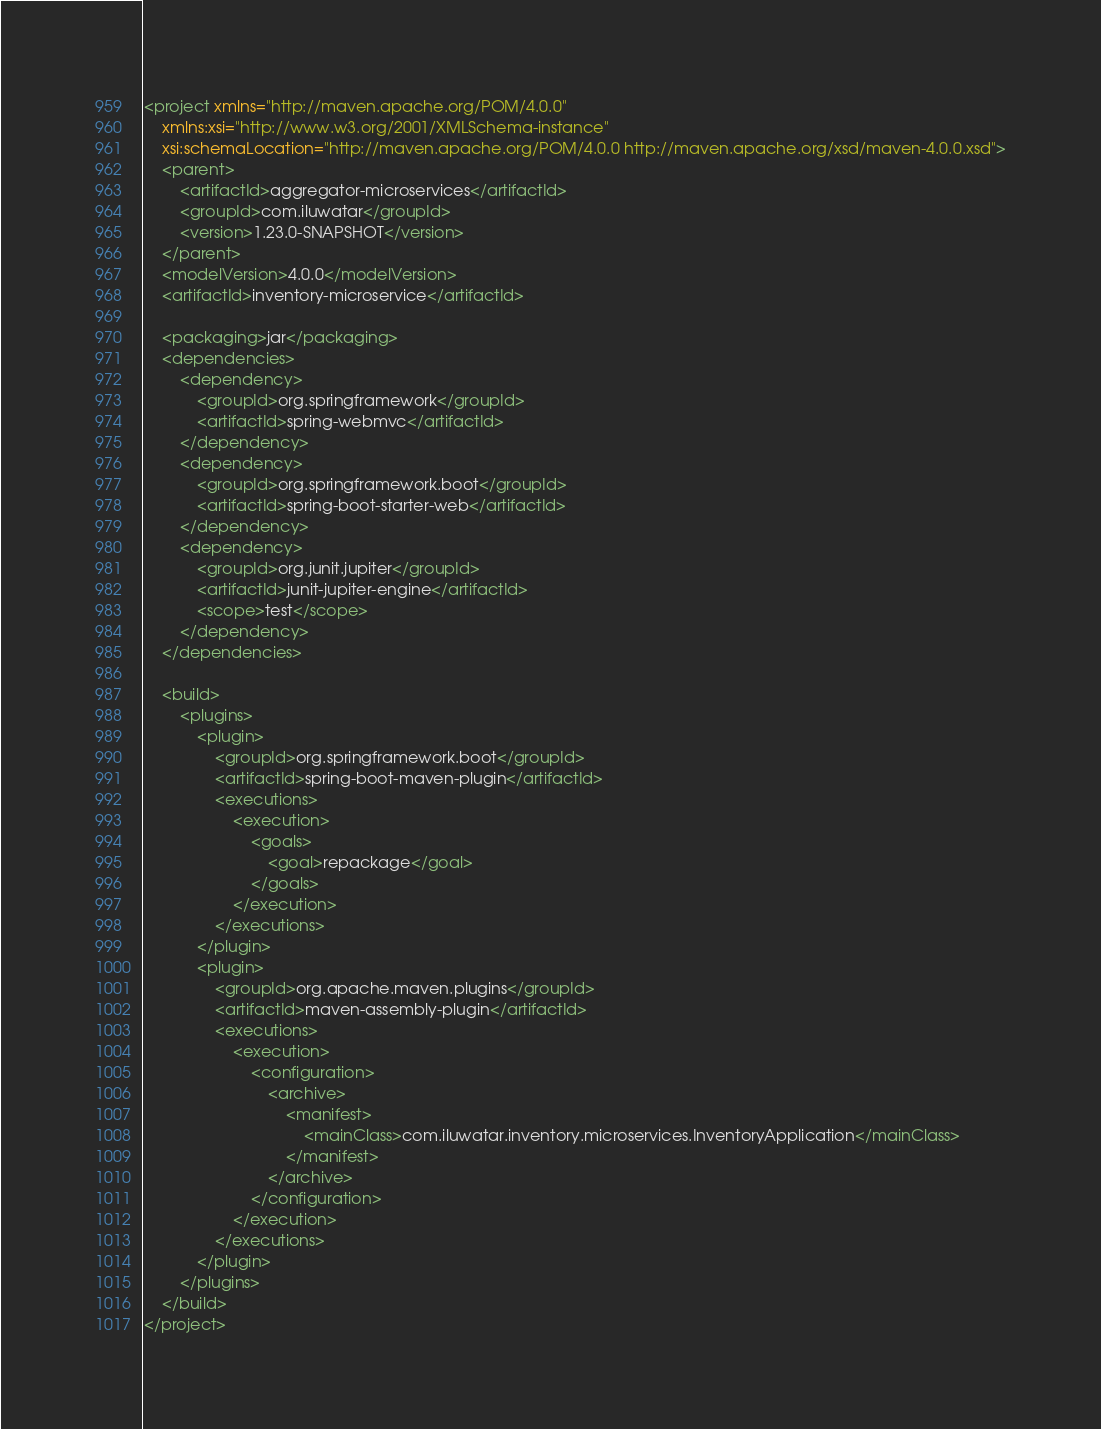Convert code to text. <code><loc_0><loc_0><loc_500><loc_500><_XML_><project xmlns="http://maven.apache.org/POM/4.0.0"
	xmlns:xsi="http://www.w3.org/2001/XMLSchema-instance"
	xsi:schemaLocation="http://maven.apache.org/POM/4.0.0 http://maven.apache.org/xsd/maven-4.0.0.xsd">
	<parent>
		<artifactId>aggregator-microservices</artifactId>
		<groupId>com.iluwatar</groupId>
		<version>1.23.0-SNAPSHOT</version>
	</parent>
	<modelVersion>4.0.0</modelVersion>
	<artifactId>inventory-microservice</artifactId>

	<packaging>jar</packaging>
	<dependencies>
		<dependency>
			<groupId>org.springframework</groupId>
			<artifactId>spring-webmvc</artifactId>
		</dependency>
		<dependency>
			<groupId>org.springframework.boot</groupId>
			<artifactId>spring-boot-starter-web</artifactId>
		</dependency>
		<dependency>
			<groupId>org.junit.jupiter</groupId>
			<artifactId>junit-jupiter-engine</artifactId>
			<scope>test</scope>
		</dependency>
	</dependencies>

	<build>
		<plugins>
			<plugin>
				<groupId>org.springframework.boot</groupId>
				<artifactId>spring-boot-maven-plugin</artifactId>
				<executions>
					<execution>
						<goals>
							<goal>repackage</goal>
						</goals>
					</execution>
				</executions>
			</plugin>
			<plugin>
				<groupId>org.apache.maven.plugins</groupId>
				<artifactId>maven-assembly-plugin</artifactId>
				<executions>
					<execution>
						<configuration>
							<archive>
								<manifest>
									<mainClass>com.iluwatar.inventory.microservices.InventoryApplication</mainClass>
								</manifest>
							</archive>
						</configuration>
					</execution>
				</executions>
			</plugin>
		</plugins>
	</build>
</project>
</code> 